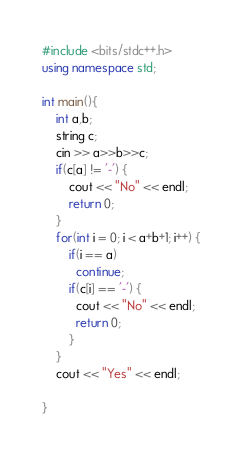Convert code to text. <code><loc_0><loc_0><loc_500><loc_500><_C++_>#include <bits/stdc++.h>
using namespace std;

int main(){
	int a,b;
  	string c;
  	cin >> a>>b>>c;
	if(c[a] != '-') {
      	cout << "No" << endl;
      	return 0;
    }
  	for(int i = 0; i < a+b+1; i++) {
		if(i == a)
          continue;
        if(c[i] == '-') {
          cout << "No" << endl;
          return 0;
	    }
    }
	cout << "Yes" << endl;
    
}
</code> 